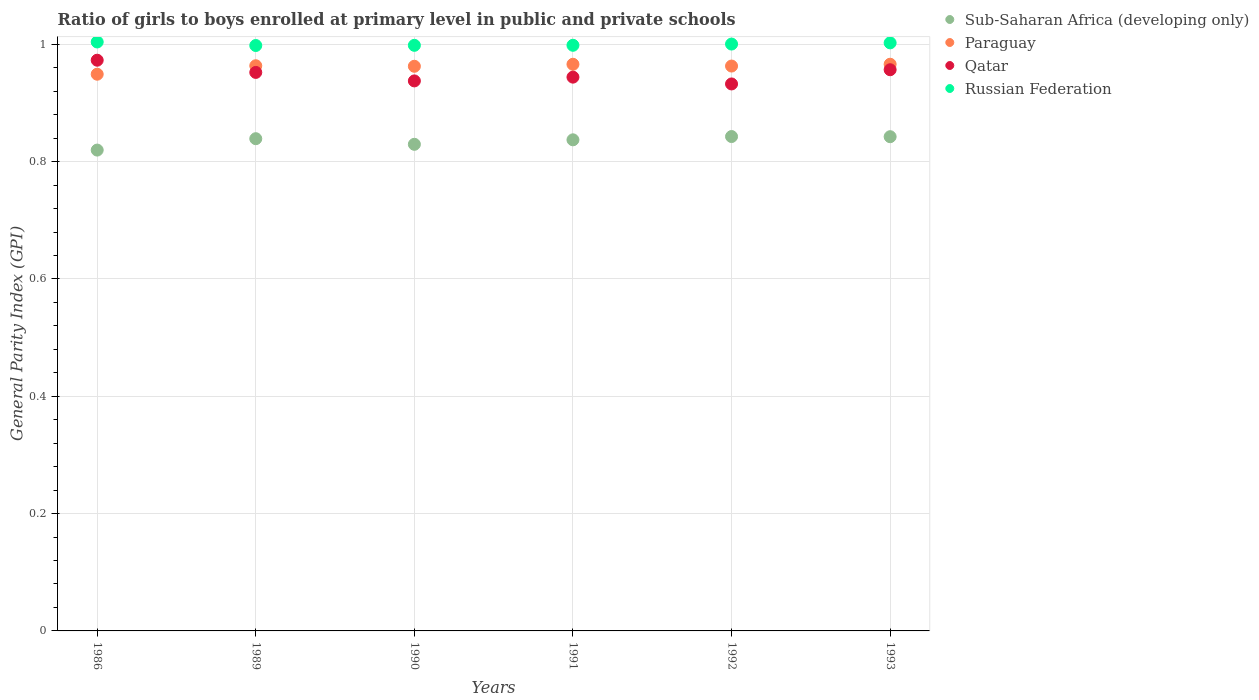How many different coloured dotlines are there?
Keep it short and to the point. 4. What is the general parity index in Sub-Saharan Africa (developing only) in 1989?
Ensure brevity in your answer.  0.84. Across all years, what is the maximum general parity index in Russian Federation?
Your response must be concise. 1. Across all years, what is the minimum general parity index in Sub-Saharan Africa (developing only)?
Offer a very short reply. 0.82. In which year was the general parity index in Qatar maximum?
Give a very brief answer. 1986. What is the total general parity index in Qatar in the graph?
Keep it short and to the point. 5.7. What is the difference between the general parity index in Sub-Saharan Africa (developing only) in 1990 and that in 1991?
Give a very brief answer. -0.01. What is the difference between the general parity index in Paraguay in 1992 and the general parity index in Qatar in 1986?
Your answer should be very brief. -0.01. What is the average general parity index in Paraguay per year?
Provide a succinct answer. 0.96. In the year 1986, what is the difference between the general parity index in Paraguay and general parity index in Sub-Saharan Africa (developing only)?
Give a very brief answer. 0.13. In how many years, is the general parity index in Sub-Saharan Africa (developing only) greater than 0.16?
Make the answer very short. 6. What is the ratio of the general parity index in Paraguay in 1991 to that in 1992?
Provide a succinct answer. 1. Is the general parity index in Paraguay in 1989 less than that in 1990?
Offer a very short reply. No. Is the difference between the general parity index in Paraguay in 1986 and 1992 greater than the difference between the general parity index in Sub-Saharan Africa (developing only) in 1986 and 1992?
Your response must be concise. Yes. What is the difference between the highest and the second highest general parity index in Russian Federation?
Offer a terse response. 0. What is the difference between the highest and the lowest general parity index in Russian Federation?
Offer a very short reply. 0.01. In how many years, is the general parity index in Qatar greater than the average general parity index in Qatar taken over all years?
Your answer should be very brief. 3. How many years are there in the graph?
Provide a succinct answer. 6. What is the difference between two consecutive major ticks on the Y-axis?
Your response must be concise. 0.2. Does the graph contain grids?
Keep it short and to the point. Yes. How many legend labels are there?
Your answer should be very brief. 4. How are the legend labels stacked?
Your answer should be very brief. Vertical. What is the title of the graph?
Offer a terse response. Ratio of girls to boys enrolled at primary level in public and private schools. Does "South Asia" appear as one of the legend labels in the graph?
Keep it short and to the point. No. What is the label or title of the Y-axis?
Provide a short and direct response. General Parity Index (GPI). What is the General Parity Index (GPI) in Sub-Saharan Africa (developing only) in 1986?
Your answer should be compact. 0.82. What is the General Parity Index (GPI) in Paraguay in 1986?
Keep it short and to the point. 0.95. What is the General Parity Index (GPI) of Qatar in 1986?
Your answer should be compact. 0.97. What is the General Parity Index (GPI) in Russian Federation in 1986?
Give a very brief answer. 1. What is the General Parity Index (GPI) of Sub-Saharan Africa (developing only) in 1989?
Your answer should be compact. 0.84. What is the General Parity Index (GPI) of Paraguay in 1989?
Provide a short and direct response. 0.96. What is the General Parity Index (GPI) in Qatar in 1989?
Ensure brevity in your answer.  0.95. What is the General Parity Index (GPI) in Russian Federation in 1989?
Your response must be concise. 1. What is the General Parity Index (GPI) of Sub-Saharan Africa (developing only) in 1990?
Provide a succinct answer. 0.83. What is the General Parity Index (GPI) of Paraguay in 1990?
Your answer should be very brief. 0.96. What is the General Parity Index (GPI) of Qatar in 1990?
Your answer should be very brief. 0.94. What is the General Parity Index (GPI) in Russian Federation in 1990?
Provide a succinct answer. 1. What is the General Parity Index (GPI) in Sub-Saharan Africa (developing only) in 1991?
Offer a very short reply. 0.84. What is the General Parity Index (GPI) in Paraguay in 1991?
Give a very brief answer. 0.97. What is the General Parity Index (GPI) of Qatar in 1991?
Give a very brief answer. 0.94. What is the General Parity Index (GPI) of Russian Federation in 1991?
Ensure brevity in your answer.  1. What is the General Parity Index (GPI) of Sub-Saharan Africa (developing only) in 1992?
Your answer should be compact. 0.84. What is the General Parity Index (GPI) of Paraguay in 1992?
Ensure brevity in your answer.  0.96. What is the General Parity Index (GPI) of Qatar in 1992?
Your answer should be compact. 0.93. What is the General Parity Index (GPI) of Russian Federation in 1992?
Give a very brief answer. 1. What is the General Parity Index (GPI) of Sub-Saharan Africa (developing only) in 1993?
Your answer should be compact. 0.84. What is the General Parity Index (GPI) in Paraguay in 1993?
Provide a succinct answer. 0.97. What is the General Parity Index (GPI) of Qatar in 1993?
Your answer should be compact. 0.96. What is the General Parity Index (GPI) in Russian Federation in 1993?
Your answer should be very brief. 1. Across all years, what is the maximum General Parity Index (GPI) of Sub-Saharan Africa (developing only)?
Ensure brevity in your answer.  0.84. Across all years, what is the maximum General Parity Index (GPI) of Paraguay?
Offer a terse response. 0.97. Across all years, what is the maximum General Parity Index (GPI) of Qatar?
Ensure brevity in your answer.  0.97. Across all years, what is the maximum General Parity Index (GPI) in Russian Federation?
Keep it short and to the point. 1. Across all years, what is the minimum General Parity Index (GPI) of Sub-Saharan Africa (developing only)?
Keep it short and to the point. 0.82. Across all years, what is the minimum General Parity Index (GPI) of Paraguay?
Provide a succinct answer. 0.95. Across all years, what is the minimum General Parity Index (GPI) in Qatar?
Your answer should be very brief. 0.93. Across all years, what is the minimum General Parity Index (GPI) in Russian Federation?
Provide a short and direct response. 1. What is the total General Parity Index (GPI) of Sub-Saharan Africa (developing only) in the graph?
Your answer should be compact. 5.01. What is the total General Parity Index (GPI) in Paraguay in the graph?
Make the answer very short. 5.77. What is the total General Parity Index (GPI) of Qatar in the graph?
Offer a very short reply. 5.7. What is the total General Parity Index (GPI) in Russian Federation in the graph?
Give a very brief answer. 6. What is the difference between the General Parity Index (GPI) of Sub-Saharan Africa (developing only) in 1986 and that in 1989?
Ensure brevity in your answer.  -0.02. What is the difference between the General Parity Index (GPI) in Paraguay in 1986 and that in 1989?
Your answer should be very brief. -0.01. What is the difference between the General Parity Index (GPI) of Qatar in 1986 and that in 1989?
Ensure brevity in your answer.  0.02. What is the difference between the General Parity Index (GPI) in Russian Federation in 1986 and that in 1989?
Your answer should be compact. 0.01. What is the difference between the General Parity Index (GPI) in Sub-Saharan Africa (developing only) in 1986 and that in 1990?
Your answer should be compact. -0.01. What is the difference between the General Parity Index (GPI) in Paraguay in 1986 and that in 1990?
Offer a terse response. -0.01. What is the difference between the General Parity Index (GPI) of Qatar in 1986 and that in 1990?
Your answer should be compact. 0.04. What is the difference between the General Parity Index (GPI) in Russian Federation in 1986 and that in 1990?
Make the answer very short. 0.01. What is the difference between the General Parity Index (GPI) in Sub-Saharan Africa (developing only) in 1986 and that in 1991?
Your answer should be compact. -0.02. What is the difference between the General Parity Index (GPI) of Paraguay in 1986 and that in 1991?
Make the answer very short. -0.02. What is the difference between the General Parity Index (GPI) of Qatar in 1986 and that in 1991?
Offer a very short reply. 0.03. What is the difference between the General Parity Index (GPI) of Russian Federation in 1986 and that in 1991?
Keep it short and to the point. 0.01. What is the difference between the General Parity Index (GPI) of Sub-Saharan Africa (developing only) in 1986 and that in 1992?
Offer a terse response. -0.02. What is the difference between the General Parity Index (GPI) in Paraguay in 1986 and that in 1992?
Your answer should be very brief. -0.01. What is the difference between the General Parity Index (GPI) in Qatar in 1986 and that in 1992?
Your response must be concise. 0.04. What is the difference between the General Parity Index (GPI) of Russian Federation in 1986 and that in 1992?
Your response must be concise. 0. What is the difference between the General Parity Index (GPI) in Sub-Saharan Africa (developing only) in 1986 and that in 1993?
Your answer should be very brief. -0.02. What is the difference between the General Parity Index (GPI) of Paraguay in 1986 and that in 1993?
Provide a succinct answer. -0.02. What is the difference between the General Parity Index (GPI) of Qatar in 1986 and that in 1993?
Make the answer very short. 0.02. What is the difference between the General Parity Index (GPI) of Russian Federation in 1986 and that in 1993?
Offer a terse response. 0. What is the difference between the General Parity Index (GPI) of Sub-Saharan Africa (developing only) in 1989 and that in 1990?
Make the answer very short. 0.01. What is the difference between the General Parity Index (GPI) in Paraguay in 1989 and that in 1990?
Your answer should be very brief. 0. What is the difference between the General Parity Index (GPI) in Qatar in 1989 and that in 1990?
Your response must be concise. 0.01. What is the difference between the General Parity Index (GPI) of Russian Federation in 1989 and that in 1990?
Your answer should be compact. -0. What is the difference between the General Parity Index (GPI) of Sub-Saharan Africa (developing only) in 1989 and that in 1991?
Make the answer very short. 0. What is the difference between the General Parity Index (GPI) in Paraguay in 1989 and that in 1991?
Ensure brevity in your answer.  -0. What is the difference between the General Parity Index (GPI) in Qatar in 1989 and that in 1991?
Offer a very short reply. 0.01. What is the difference between the General Parity Index (GPI) of Russian Federation in 1989 and that in 1991?
Offer a terse response. -0. What is the difference between the General Parity Index (GPI) of Sub-Saharan Africa (developing only) in 1989 and that in 1992?
Give a very brief answer. -0. What is the difference between the General Parity Index (GPI) in Qatar in 1989 and that in 1992?
Ensure brevity in your answer.  0.02. What is the difference between the General Parity Index (GPI) in Russian Federation in 1989 and that in 1992?
Your answer should be compact. -0. What is the difference between the General Parity Index (GPI) of Sub-Saharan Africa (developing only) in 1989 and that in 1993?
Your answer should be very brief. -0. What is the difference between the General Parity Index (GPI) of Paraguay in 1989 and that in 1993?
Offer a terse response. -0. What is the difference between the General Parity Index (GPI) of Qatar in 1989 and that in 1993?
Your answer should be compact. -0. What is the difference between the General Parity Index (GPI) of Russian Federation in 1989 and that in 1993?
Make the answer very short. -0. What is the difference between the General Parity Index (GPI) in Sub-Saharan Africa (developing only) in 1990 and that in 1991?
Give a very brief answer. -0.01. What is the difference between the General Parity Index (GPI) in Paraguay in 1990 and that in 1991?
Ensure brevity in your answer.  -0. What is the difference between the General Parity Index (GPI) in Qatar in 1990 and that in 1991?
Your answer should be compact. -0.01. What is the difference between the General Parity Index (GPI) in Russian Federation in 1990 and that in 1991?
Provide a short and direct response. -0. What is the difference between the General Parity Index (GPI) in Sub-Saharan Africa (developing only) in 1990 and that in 1992?
Offer a terse response. -0.01. What is the difference between the General Parity Index (GPI) in Paraguay in 1990 and that in 1992?
Your response must be concise. -0. What is the difference between the General Parity Index (GPI) in Qatar in 1990 and that in 1992?
Ensure brevity in your answer.  0.01. What is the difference between the General Parity Index (GPI) of Russian Federation in 1990 and that in 1992?
Your answer should be compact. -0. What is the difference between the General Parity Index (GPI) of Sub-Saharan Africa (developing only) in 1990 and that in 1993?
Your answer should be compact. -0.01. What is the difference between the General Parity Index (GPI) in Paraguay in 1990 and that in 1993?
Give a very brief answer. -0. What is the difference between the General Parity Index (GPI) in Qatar in 1990 and that in 1993?
Offer a terse response. -0.02. What is the difference between the General Parity Index (GPI) in Russian Federation in 1990 and that in 1993?
Your answer should be very brief. -0. What is the difference between the General Parity Index (GPI) in Sub-Saharan Africa (developing only) in 1991 and that in 1992?
Provide a succinct answer. -0.01. What is the difference between the General Parity Index (GPI) of Paraguay in 1991 and that in 1992?
Offer a very short reply. 0. What is the difference between the General Parity Index (GPI) of Qatar in 1991 and that in 1992?
Ensure brevity in your answer.  0.01. What is the difference between the General Parity Index (GPI) in Russian Federation in 1991 and that in 1992?
Your answer should be compact. -0. What is the difference between the General Parity Index (GPI) of Sub-Saharan Africa (developing only) in 1991 and that in 1993?
Offer a terse response. -0.01. What is the difference between the General Parity Index (GPI) of Paraguay in 1991 and that in 1993?
Your answer should be compact. -0. What is the difference between the General Parity Index (GPI) of Qatar in 1991 and that in 1993?
Provide a short and direct response. -0.01. What is the difference between the General Parity Index (GPI) of Russian Federation in 1991 and that in 1993?
Give a very brief answer. -0. What is the difference between the General Parity Index (GPI) in Paraguay in 1992 and that in 1993?
Your answer should be compact. -0. What is the difference between the General Parity Index (GPI) in Qatar in 1992 and that in 1993?
Make the answer very short. -0.02. What is the difference between the General Parity Index (GPI) of Russian Federation in 1992 and that in 1993?
Give a very brief answer. -0. What is the difference between the General Parity Index (GPI) of Sub-Saharan Africa (developing only) in 1986 and the General Parity Index (GPI) of Paraguay in 1989?
Provide a short and direct response. -0.14. What is the difference between the General Parity Index (GPI) of Sub-Saharan Africa (developing only) in 1986 and the General Parity Index (GPI) of Qatar in 1989?
Keep it short and to the point. -0.13. What is the difference between the General Parity Index (GPI) in Sub-Saharan Africa (developing only) in 1986 and the General Parity Index (GPI) in Russian Federation in 1989?
Your response must be concise. -0.18. What is the difference between the General Parity Index (GPI) in Paraguay in 1986 and the General Parity Index (GPI) in Qatar in 1989?
Provide a succinct answer. -0. What is the difference between the General Parity Index (GPI) of Paraguay in 1986 and the General Parity Index (GPI) of Russian Federation in 1989?
Keep it short and to the point. -0.05. What is the difference between the General Parity Index (GPI) in Qatar in 1986 and the General Parity Index (GPI) in Russian Federation in 1989?
Keep it short and to the point. -0.03. What is the difference between the General Parity Index (GPI) of Sub-Saharan Africa (developing only) in 1986 and the General Parity Index (GPI) of Paraguay in 1990?
Your answer should be compact. -0.14. What is the difference between the General Parity Index (GPI) in Sub-Saharan Africa (developing only) in 1986 and the General Parity Index (GPI) in Qatar in 1990?
Ensure brevity in your answer.  -0.12. What is the difference between the General Parity Index (GPI) in Sub-Saharan Africa (developing only) in 1986 and the General Parity Index (GPI) in Russian Federation in 1990?
Provide a succinct answer. -0.18. What is the difference between the General Parity Index (GPI) in Paraguay in 1986 and the General Parity Index (GPI) in Qatar in 1990?
Offer a very short reply. 0.01. What is the difference between the General Parity Index (GPI) in Paraguay in 1986 and the General Parity Index (GPI) in Russian Federation in 1990?
Give a very brief answer. -0.05. What is the difference between the General Parity Index (GPI) in Qatar in 1986 and the General Parity Index (GPI) in Russian Federation in 1990?
Offer a very short reply. -0.03. What is the difference between the General Parity Index (GPI) in Sub-Saharan Africa (developing only) in 1986 and the General Parity Index (GPI) in Paraguay in 1991?
Your answer should be very brief. -0.15. What is the difference between the General Parity Index (GPI) of Sub-Saharan Africa (developing only) in 1986 and the General Parity Index (GPI) of Qatar in 1991?
Provide a short and direct response. -0.12. What is the difference between the General Parity Index (GPI) of Sub-Saharan Africa (developing only) in 1986 and the General Parity Index (GPI) of Russian Federation in 1991?
Provide a succinct answer. -0.18. What is the difference between the General Parity Index (GPI) of Paraguay in 1986 and the General Parity Index (GPI) of Qatar in 1991?
Ensure brevity in your answer.  0.01. What is the difference between the General Parity Index (GPI) of Paraguay in 1986 and the General Parity Index (GPI) of Russian Federation in 1991?
Your response must be concise. -0.05. What is the difference between the General Parity Index (GPI) in Qatar in 1986 and the General Parity Index (GPI) in Russian Federation in 1991?
Provide a short and direct response. -0.03. What is the difference between the General Parity Index (GPI) of Sub-Saharan Africa (developing only) in 1986 and the General Parity Index (GPI) of Paraguay in 1992?
Your answer should be compact. -0.14. What is the difference between the General Parity Index (GPI) in Sub-Saharan Africa (developing only) in 1986 and the General Parity Index (GPI) in Qatar in 1992?
Offer a very short reply. -0.11. What is the difference between the General Parity Index (GPI) of Sub-Saharan Africa (developing only) in 1986 and the General Parity Index (GPI) of Russian Federation in 1992?
Offer a very short reply. -0.18. What is the difference between the General Parity Index (GPI) of Paraguay in 1986 and the General Parity Index (GPI) of Qatar in 1992?
Your answer should be very brief. 0.02. What is the difference between the General Parity Index (GPI) of Paraguay in 1986 and the General Parity Index (GPI) of Russian Federation in 1992?
Provide a short and direct response. -0.05. What is the difference between the General Parity Index (GPI) in Qatar in 1986 and the General Parity Index (GPI) in Russian Federation in 1992?
Provide a short and direct response. -0.03. What is the difference between the General Parity Index (GPI) in Sub-Saharan Africa (developing only) in 1986 and the General Parity Index (GPI) in Paraguay in 1993?
Give a very brief answer. -0.15. What is the difference between the General Parity Index (GPI) in Sub-Saharan Africa (developing only) in 1986 and the General Parity Index (GPI) in Qatar in 1993?
Offer a terse response. -0.14. What is the difference between the General Parity Index (GPI) in Sub-Saharan Africa (developing only) in 1986 and the General Parity Index (GPI) in Russian Federation in 1993?
Ensure brevity in your answer.  -0.18. What is the difference between the General Parity Index (GPI) of Paraguay in 1986 and the General Parity Index (GPI) of Qatar in 1993?
Your answer should be compact. -0.01. What is the difference between the General Parity Index (GPI) in Paraguay in 1986 and the General Parity Index (GPI) in Russian Federation in 1993?
Offer a terse response. -0.05. What is the difference between the General Parity Index (GPI) in Qatar in 1986 and the General Parity Index (GPI) in Russian Federation in 1993?
Keep it short and to the point. -0.03. What is the difference between the General Parity Index (GPI) of Sub-Saharan Africa (developing only) in 1989 and the General Parity Index (GPI) of Paraguay in 1990?
Keep it short and to the point. -0.12. What is the difference between the General Parity Index (GPI) in Sub-Saharan Africa (developing only) in 1989 and the General Parity Index (GPI) in Qatar in 1990?
Provide a short and direct response. -0.1. What is the difference between the General Parity Index (GPI) of Sub-Saharan Africa (developing only) in 1989 and the General Parity Index (GPI) of Russian Federation in 1990?
Your answer should be very brief. -0.16. What is the difference between the General Parity Index (GPI) in Paraguay in 1989 and the General Parity Index (GPI) in Qatar in 1990?
Your answer should be compact. 0.03. What is the difference between the General Parity Index (GPI) in Paraguay in 1989 and the General Parity Index (GPI) in Russian Federation in 1990?
Ensure brevity in your answer.  -0.03. What is the difference between the General Parity Index (GPI) of Qatar in 1989 and the General Parity Index (GPI) of Russian Federation in 1990?
Your response must be concise. -0.05. What is the difference between the General Parity Index (GPI) of Sub-Saharan Africa (developing only) in 1989 and the General Parity Index (GPI) of Paraguay in 1991?
Your response must be concise. -0.13. What is the difference between the General Parity Index (GPI) of Sub-Saharan Africa (developing only) in 1989 and the General Parity Index (GPI) of Qatar in 1991?
Offer a terse response. -0.1. What is the difference between the General Parity Index (GPI) in Sub-Saharan Africa (developing only) in 1989 and the General Parity Index (GPI) in Russian Federation in 1991?
Keep it short and to the point. -0.16. What is the difference between the General Parity Index (GPI) of Paraguay in 1989 and the General Parity Index (GPI) of Qatar in 1991?
Offer a very short reply. 0.02. What is the difference between the General Parity Index (GPI) in Paraguay in 1989 and the General Parity Index (GPI) in Russian Federation in 1991?
Offer a very short reply. -0.03. What is the difference between the General Parity Index (GPI) of Qatar in 1989 and the General Parity Index (GPI) of Russian Federation in 1991?
Provide a short and direct response. -0.05. What is the difference between the General Parity Index (GPI) in Sub-Saharan Africa (developing only) in 1989 and the General Parity Index (GPI) in Paraguay in 1992?
Ensure brevity in your answer.  -0.12. What is the difference between the General Parity Index (GPI) in Sub-Saharan Africa (developing only) in 1989 and the General Parity Index (GPI) in Qatar in 1992?
Provide a short and direct response. -0.09. What is the difference between the General Parity Index (GPI) of Sub-Saharan Africa (developing only) in 1989 and the General Parity Index (GPI) of Russian Federation in 1992?
Provide a succinct answer. -0.16. What is the difference between the General Parity Index (GPI) of Paraguay in 1989 and the General Parity Index (GPI) of Qatar in 1992?
Give a very brief answer. 0.03. What is the difference between the General Parity Index (GPI) of Paraguay in 1989 and the General Parity Index (GPI) of Russian Federation in 1992?
Give a very brief answer. -0.04. What is the difference between the General Parity Index (GPI) of Qatar in 1989 and the General Parity Index (GPI) of Russian Federation in 1992?
Keep it short and to the point. -0.05. What is the difference between the General Parity Index (GPI) of Sub-Saharan Africa (developing only) in 1989 and the General Parity Index (GPI) of Paraguay in 1993?
Keep it short and to the point. -0.13. What is the difference between the General Parity Index (GPI) of Sub-Saharan Africa (developing only) in 1989 and the General Parity Index (GPI) of Qatar in 1993?
Your response must be concise. -0.12. What is the difference between the General Parity Index (GPI) in Sub-Saharan Africa (developing only) in 1989 and the General Parity Index (GPI) in Russian Federation in 1993?
Give a very brief answer. -0.16. What is the difference between the General Parity Index (GPI) in Paraguay in 1989 and the General Parity Index (GPI) in Qatar in 1993?
Provide a short and direct response. 0.01. What is the difference between the General Parity Index (GPI) of Paraguay in 1989 and the General Parity Index (GPI) of Russian Federation in 1993?
Ensure brevity in your answer.  -0.04. What is the difference between the General Parity Index (GPI) in Qatar in 1989 and the General Parity Index (GPI) in Russian Federation in 1993?
Keep it short and to the point. -0.05. What is the difference between the General Parity Index (GPI) of Sub-Saharan Africa (developing only) in 1990 and the General Parity Index (GPI) of Paraguay in 1991?
Give a very brief answer. -0.14. What is the difference between the General Parity Index (GPI) in Sub-Saharan Africa (developing only) in 1990 and the General Parity Index (GPI) in Qatar in 1991?
Give a very brief answer. -0.11. What is the difference between the General Parity Index (GPI) of Sub-Saharan Africa (developing only) in 1990 and the General Parity Index (GPI) of Russian Federation in 1991?
Provide a short and direct response. -0.17. What is the difference between the General Parity Index (GPI) of Paraguay in 1990 and the General Parity Index (GPI) of Qatar in 1991?
Your answer should be very brief. 0.02. What is the difference between the General Parity Index (GPI) of Paraguay in 1990 and the General Parity Index (GPI) of Russian Federation in 1991?
Keep it short and to the point. -0.04. What is the difference between the General Parity Index (GPI) in Qatar in 1990 and the General Parity Index (GPI) in Russian Federation in 1991?
Provide a short and direct response. -0.06. What is the difference between the General Parity Index (GPI) in Sub-Saharan Africa (developing only) in 1990 and the General Parity Index (GPI) in Paraguay in 1992?
Provide a short and direct response. -0.13. What is the difference between the General Parity Index (GPI) of Sub-Saharan Africa (developing only) in 1990 and the General Parity Index (GPI) of Qatar in 1992?
Your answer should be very brief. -0.1. What is the difference between the General Parity Index (GPI) of Sub-Saharan Africa (developing only) in 1990 and the General Parity Index (GPI) of Russian Federation in 1992?
Offer a very short reply. -0.17. What is the difference between the General Parity Index (GPI) of Paraguay in 1990 and the General Parity Index (GPI) of Qatar in 1992?
Offer a very short reply. 0.03. What is the difference between the General Parity Index (GPI) of Paraguay in 1990 and the General Parity Index (GPI) of Russian Federation in 1992?
Give a very brief answer. -0.04. What is the difference between the General Parity Index (GPI) of Qatar in 1990 and the General Parity Index (GPI) of Russian Federation in 1992?
Your response must be concise. -0.06. What is the difference between the General Parity Index (GPI) in Sub-Saharan Africa (developing only) in 1990 and the General Parity Index (GPI) in Paraguay in 1993?
Provide a short and direct response. -0.14. What is the difference between the General Parity Index (GPI) in Sub-Saharan Africa (developing only) in 1990 and the General Parity Index (GPI) in Qatar in 1993?
Your response must be concise. -0.13. What is the difference between the General Parity Index (GPI) of Sub-Saharan Africa (developing only) in 1990 and the General Parity Index (GPI) of Russian Federation in 1993?
Give a very brief answer. -0.17. What is the difference between the General Parity Index (GPI) of Paraguay in 1990 and the General Parity Index (GPI) of Qatar in 1993?
Your response must be concise. 0.01. What is the difference between the General Parity Index (GPI) of Paraguay in 1990 and the General Parity Index (GPI) of Russian Federation in 1993?
Offer a terse response. -0.04. What is the difference between the General Parity Index (GPI) in Qatar in 1990 and the General Parity Index (GPI) in Russian Federation in 1993?
Offer a very short reply. -0.06. What is the difference between the General Parity Index (GPI) of Sub-Saharan Africa (developing only) in 1991 and the General Parity Index (GPI) of Paraguay in 1992?
Your response must be concise. -0.13. What is the difference between the General Parity Index (GPI) of Sub-Saharan Africa (developing only) in 1991 and the General Parity Index (GPI) of Qatar in 1992?
Your response must be concise. -0.1. What is the difference between the General Parity Index (GPI) of Sub-Saharan Africa (developing only) in 1991 and the General Parity Index (GPI) of Russian Federation in 1992?
Your answer should be compact. -0.16. What is the difference between the General Parity Index (GPI) of Paraguay in 1991 and the General Parity Index (GPI) of Qatar in 1992?
Provide a succinct answer. 0.03. What is the difference between the General Parity Index (GPI) in Paraguay in 1991 and the General Parity Index (GPI) in Russian Federation in 1992?
Offer a terse response. -0.03. What is the difference between the General Parity Index (GPI) of Qatar in 1991 and the General Parity Index (GPI) of Russian Federation in 1992?
Your response must be concise. -0.06. What is the difference between the General Parity Index (GPI) in Sub-Saharan Africa (developing only) in 1991 and the General Parity Index (GPI) in Paraguay in 1993?
Your response must be concise. -0.13. What is the difference between the General Parity Index (GPI) of Sub-Saharan Africa (developing only) in 1991 and the General Parity Index (GPI) of Qatar in 1993?
Ensure brevity in your answer.  -0.12. What is the difference between the General Parity Index (GPI) of Sub-Saharan Africa (developing only) in 1991 and the General Parity Index (GPI) of Russian Federation in 1993?
Ensure brevity in your answer.  -0.17. What is the difference between the General Parity Index (GPI) of Paraguay in 1991 and the General Parity Index (GPI) of Qatar in 1993?
Give a very brief answer. 0.01. What is the difference between the General Parity Index (GPI) in Paraguay in 1991 and the General Parity Index (GPI) in Russian Federation in 1993?
Your answer should be very brief. -0.04. What is the difference between the General Parity Index (GPI) of Qatar in 1991 and the General Parity Index (GPI) of Russian Federation in 1993?
Make the answer very short. -0.06. What is the difference between the General Parity Index (GPI) in Sub-Saharan Africa (developing only) in 1992 and the General Parity Index (GPI) in Paraguay in 1993?
Offer a very short reply. -0.12. What is the difference between the General Parity Index (GPI) in Sub-Saharan Africa (developing only) in 1992 and the General Parity Index (GPI) in Qatar in 1993?
Offer a terse response. -0.11. What is the difference between the General Parity Index (GPI) of Sub-Saharan Africa (developing only) in 1992 and the General Parity Index (GPI) of Russian Federation in 1993?
Provide a succinct answer. -0.16. What is the difference between the General Parity Index (GPI) in Paraguay in 1992 and the General Parity Index (GPI) in Qatar in 1993?
Provide a short and direct response. 0.01. What is the difference between the General Parity Index (GPI) in Paraguay in 1992 and the General Parity Index (GPI) in Russian Federation in 1993?
Provide a short and direct response. -0.04. What is the difference between the General Parity Index (GPI) in Qatar in 1992 and the General Parity Index (GPI) in Russian Federation in 1993?
Ensure brevity in your answer.  -0.07. What is the average General Parity Index (GPI) in Sub-Saharan Africa (developing only) per year?
Offer a very short reply. 0.84. What is the average General Parity Index (GPI) in Paraguay per year?
Your answer should be compact. 0.96. What is the average General Parity Index (GPI) in Qatar per year?
Offer a very short reply. 0.95. In the year 1986, what is the difference between the General Parity Index (GPI) of Sub-Saharan Africa (developing only) and General Parity Index (GPI) of Paraguay?
Your answer should be compact. -0.13. In the year 1986, what is the difference between the General Parity Index (GPI) of Sub-Saharan Africa (developing only) and General Parity Index (GPI) of Qatar?
Your response must be concise. -0.15. In the year 1986, what is the difference between the General Parity Index (GPI) of Sub-Saharan Africa (developing only) and General Parity Index (GPI) of Russian Federation?
Offer a terse response. -0.18. In the year 1986, what is the difference between the General Parity Index (GPI) in Paraguay and General Parity Index (GPI) in Qatar?
Your answer should be very brief. -0.02. In the year 1986, what is the difference between the General Parity Index (GPI) of Paraguay and General Parity Index (GPI) of Russian Federation?
Offer a terse response. -0.05. In the year 1986, what is the difference between the General Parity Index (GPI) of Qatar and General Parity Index (GPI) of Russian Federation?
Provide a short and direct response. -0.03. In the year 1989, what is the difference between the General Parity Index (GPI) in Sub-Saharan Africa (developing only) and General Parity Index (GPI) in Paraguay?
Your response must be concise. -0.12. In the year 1989, what is the difference between the General Parity Index (GPI) of Sub-Saharan Africa (developing only) and General Parity Index (GPI) of Qatar?
Make the answer very short. -0.11. In the year 1989, what is the difference between the General Parity Index (GPI) in Sub-Saharan Africa (developing only) and General Parity Index (GPI) in Russian Federation?
Provide a short and direct response. -0.16. In the year 1989, what is the difference between the General Parity Index (GPI) of Paraguay and General Parity Index (GPI) of Qatar?
Offer a terse response. 0.01. In the year 1989, what is the difference between the General Parity Index (GPI) in Paraguay and General Parity Index (GPI) in Russian Federation?
Ensure brevity in your answer.  -0.03. In the year 1989, what is the difference between the General Parity Index (GPI) of Qatar and General Parity Index (GPI) of Russian Federation?
Provide a short and direct response. -0.05. In the year 1990, what is the difference between the General Parity Index (GPI) of Sub-Saharan Africa (developing only) and General Parity Index (GPI) of Paraguay?
Provide a short and direct response. -0.13. In the year 1990, what is the difference between the General Parity Index (GPI) in Sub-Saharan Africa (developing only) and General Parity Index (GPI) in Qatar?
Make the answer very short. -0.11. In the year 1990, what is the difference between the General Parity Index (GPI) in Sub-Saharan Africa (developing only) and General Parity Index (GPI) in Russian Federation?
Provide a short and direct response. -0.17. In the year 1990, what is the difference between the General Parity Index (GPI) of Paraguay and General Parity Index (GPI) of Qatar?
Make the answer very short. 0.03. In the year 1990, what is the difference between the General Parity Index (GPI) in Paraguay and General Parity Index (GPI) in Russian Federation?
Ensure brevity in your answer.  -0.04. In the year 1990, what is the difference between the General Parity Index (GPI) in Qatar and General Parity Index (GPI) in Russian Federation?
Give a very brief answer. -0.06. In the year 1991, what is the difference between the General Parity Index (GPI) of Sub-Saharan Africa (developing only) and General Parity Index (GPI) of Paraguay?
Offer a very short reply. -0.13. In the year 1991, what is the difference between the General Parity Index (GPI) of Sub-Saharan Africa (developing only) and General Parity Index (GPI) of Qatar?
Provide a short and direct response. -0.11. In the year 1991, what is the difference between the General Parity Index (GPI) of Sub-Saharan Africa (developing only) and General Parity Index (GPI) of Russian Federation?
Keep it short and to the point. -0.16. In the year 1991, what is the difference between the General Parity Index (GPI) in Paraguay and General Parity Index (GPI) in Qatar?
Keep it short and to the point. 0.02. In the year 1991, what is the difference between the General Parity Index (GPI) of Paraguay and General Parity Index (GPI) of Russian Federation?
Give a very brief answer. -0.03. In the year 1991, what is the difference between the General Parity Index (GPI) of Qatar and General Parity Index (GPI) of Russian Federation?
Your answer should be compact. -0.05. In the year 1992, what is the difference between the General Parity Index (GPI) in Sub-Saharan Africa (developing only) and General Parity Index (GPI) in Paraguay?
Your answer should be very brief. -0.12. In the year 1992, what is the difference between the General Parity Index (GPI) of Sub-Saharan Africa (developing only) and General Parity Index (GPI) of Qatar?
Give a very brief answer. -0.09. In the year 1992, what is the difference between the General Parity Index (GPI) in Sub-Saharan Africa (developing only) and General Parity Index (GPI) in Russian Federation?
Make the answer very short. -0.16. In the year 1992, what is the difference between the General Parity Index (GPI) in Paraguay and General Parity Index (GPI) in Qatar?
Keep it short and to the point. 0.03. In the year 1992, what is the difference between the General Parity Index (GPI) of Paraguay and General Parity Index (GPI) of Russian Federation?
Make the answer very short. -0.04. In the year 1992, what is the difference between the General Parity Index (GPI) of Qatar and General Parity Index (GPI) of Russian Federation?
Offer a very short reply. -0.07. In the year 1993, what is the difference between the General Parity Index (GPI) in Sub-Saharan Africa (developing only) and General Parity Index (GPI) in Paraguay?
Keep it short and to the point. -0.12. In the year 1993, what is the difference between the General Parity Index (GPI) in Sub-Saharan Africa (developing only) and General Parity Index (GPI) in Qatar?
Your response must be concise. -0.11. In the year 1993, what is the difference between the General Parity Index (GPI) of Sub-Saharan Africa (developing only) and General Parity Index (GPI) of Russian Federation?
Make the answer very short. -0.16. In the year 1993, what is the difference between the General Parity Index (GPI) of Paraguay and General Parity Index (GPI) of Qatar?
Provide a succinct answer. 0.01. In the year 1993, what is the difference between the General Parity Index (GPI) in Paraguay and General Parity Index (GPI) in Russian Federation?
Make the answer very short. -0.04. In the year 1993, what is the difference between the General Parity Index (GPI) in Qatar and General Parity Index (GPI) in Russian Federation?
Provide a succinct answer. -0.05. What is the ratio of the General Parity Index (GPI) of Sub-Saharan Africa (developing only) in 1986 to that in 1989?
Offer a very short reply. 0.98. What is the ratio of the General Parity Index (GPI) in Qatar in 1986 to that in 1989?
Ensure brevity in your answer.  1.02. What is the ratio of the General Parity Index (GPI) in Russian Federation in 1986 to that in 1989?
Ensure brevity in your answer.  1.01. What is the ratio of the General Parity Index (GPI) in Sub-Saharan Africa (developing only) in 1986 to that in 1990?
Offer a terse response. 0.99. What is the ratio of the General Parity Index (GPI) in Qatar in 1986 to that in 1990?
Make the answer very short. 1.04. What is the ratio of the General Parity Index (GPI) in Russian Federation in 1986 to that in 1990?
Offer a terse response. 1.01. What is the ratio of the General Parity Index (GPI) in Sub-Saharan Africa (developing only) in 1986 to that in 1991?
Ensure brevity in your answer.  0.98. What is the ratio of the General Parity Index (GPI) of Paraguay in 1986 to that in 1991?
Your answer should be compact. 0.98. What is the ratio of the General Parity Index (GPI) of Qatar in 1986 to that in 1991?
Give a very brief answer. 1.03. What is the ratio of the General Parity Index (GPI) in Russian Federation in 1986 to that in 1991?
Your answer should be compact. 1.01. What is the ratio of the General Parity Index (GPI) of Sub-Saharan Africa (developing only) in 1986 to that in 1992?
Make the answer very short. 0.97. What is the ratio of the General Parity Index (GPI) in Paraguay in 1986 to that in 1992?
Offer a terse response. 0.99. What is the ratio of the General Parity Index (GPI) of Qatar in 1986 to that in 1992?
Provide a short and direct response. 1.04. What is the ratio of the General Parity Index (GPI) of Sub-Saharan Africa (developing only) in 1986 to that in 1993?
Your answer should be very brief. 0.97. What is the ratio of the General Parity Index (GPI) in Paraguay in 1986 to that in 1993?
Offer a terse response. 0.98. What is the ratio of the General Parity Index (GPI) of Qatar in 1986 to that in 1993?
Make the answer very short. 1.02. What is the ratio of the General Parity Index (GPI) of Russian Federation in 1986 to that in 1993?
Keep it short and to the point. 1. What is the ratio of the General Parity Index (GPI) of Sub-Saharan Africa (developing only) in 1989 to that in 1990?
Offer a very short reply. 1.01. What is the ratio of the General Parity Index (GPI) of Paraguay in 1989 to that in 1990?
Offer a terse response. 1. What is the ratio of the General Parity Index (GPI) in Qatar in 1989 to that in 1990?
Offer a terse response. 1.02. What is the ratio of the General Parity Index (GPI) in Russian Federation in 1989 to that in 1990?
Keep it short and to the point. 1. What is the ratio of the General Parity Index (GPI) in Paraguay in 1989 to that in 1991?
Offer a very short reply. 1. What is the ratio of the General Parity Index (GPI) in Qatar in 1989 to that in 1991?
Ensure brevity in your answer.  1.01. What is the ratio of the General Parity Index (GPI) of Russian Federation in 1989 to that in 1991?
Ensure brevity in your answer.  1. What is the ratio of the General Parity Index (GPI) in Paraguay in 1989 to that in 1992?
Offer a very short reply. 1. What is the ratio of the General Parity Index (GPI) in Qatar in 1989 to that in 1992?
Provide a succinct answer. 1.02. What is the ratio of the General Parity Index (GPI) of Sub-Saharan Africa (developing only) in 1989 to that in 1993?
Your answer should be compact. 1. What is the ratio of the General Parity Index (GPI) in Sub-Saharan Africa (developing only) in 1990 to that in 1991?
Ensure brevity in your answer.  0.99. What is the ratio of the General Parity Index (GPI) in Paraguay in 1990 to that in 1991?
Ensure brevity in your answer.  1. What is the ratio of the General Parity Index (GPI) of Russian Federation in 1990 to that in 1991?
Offer a very short reply. 1. What is the ratio of the General Parity Index (GPI) of Sub-Saharan Africa (developing only) in 1990 to that in 1992?
Provide a succinct answer. 0.98. What is the ratio of the General Parity Index (GPI) of Paraguay in 1990 to that in 1992?
Keep it short and to the point. 1. What is the ratio of the General Parity Index (GPI) in Sub-Saharan Africa (developing only) in 1990 to that in 1993?
Your answer should be very brief. 0.98. What is the ratio of the General Parity Index (GPI) in Qatar in 1990 to that in 1993?
Offer a very short reply. 0.98. What is the ratio of the General Parity Index (GPI) of Sub-Saharan Africa (developing only) in 1991 to that in 1992?
Keep it short and to the point. 0.99. What is the ratio of the General Parity Index (GPI) in Paraguay in 1991 to that in 1992?
Offer a terse response. 1. What is the ratio of the General Parity Index (GPI) in Qatar in 1991 to that in 1992?
Your answer should be very brief. 1.01. What is the ratio of the General Parity Index (GPI) of Qatar in 1991 to that in 1993?
Make the answer very short. 0.99. What is the ratio of the General Parity Index (GPI) in Russian Federation in 1991 to that in 1993?
Ensure brevity in your answer.  1. What is the ratio of the General Parity Index (GPI) in Sub-Saharan Africa (developing only) in 1992 to that in 1993?
Provide a succinct answer. 1. What is the ratio of the General Parity Index (GPI) of Qatar in 1992 to that in 1993?
Offer a very short reply. 0.97. What is the difference between the highest and the second highest General Parity Index (GPI) in Sub-Saharan Africa (developing only)?
Provide a short and direct response. 0. What is the difference between the highest and the second highest General Parity Index (GPI) in Paraguay?
Give a very brief answer. 0. What is the difference between the highest and the second highest General Parity Index (GPI) of Qatar?
Give a very brief answer. 0.02. What is the difference between the highest and the second highest General Parity Index (GPI) of Russian Federation?
Offer a terse response. 0. What is the difference between the highest and the lowest General Parity Index (GPI) of Sub-Saharan Africa (developing only)?
Your answer should be compact. 0.02. What is the difference between the highest and the lowest General Parity Index (GPI) of Paraguay?
Your answer should be very brief. 0.02. What is the difference between the highest and the lowest General Parity Index (GPI) in Qatar?
Offer a terse response. 0.04. What is the difference between the highest and the lowest General Parity Index (GPI) of Russian Federation?
Your response must be concise. 0.01. 